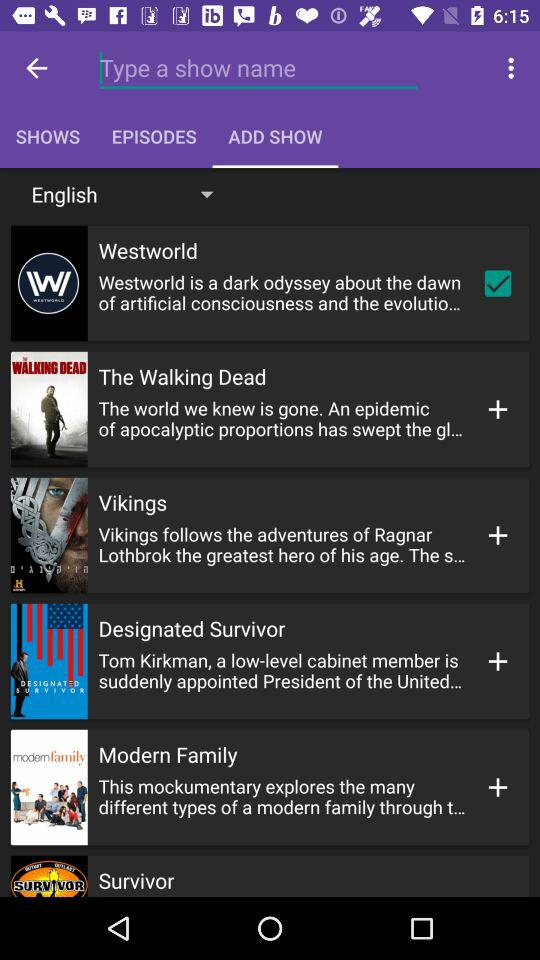Which option is checked? The checked option is "Westworld". 